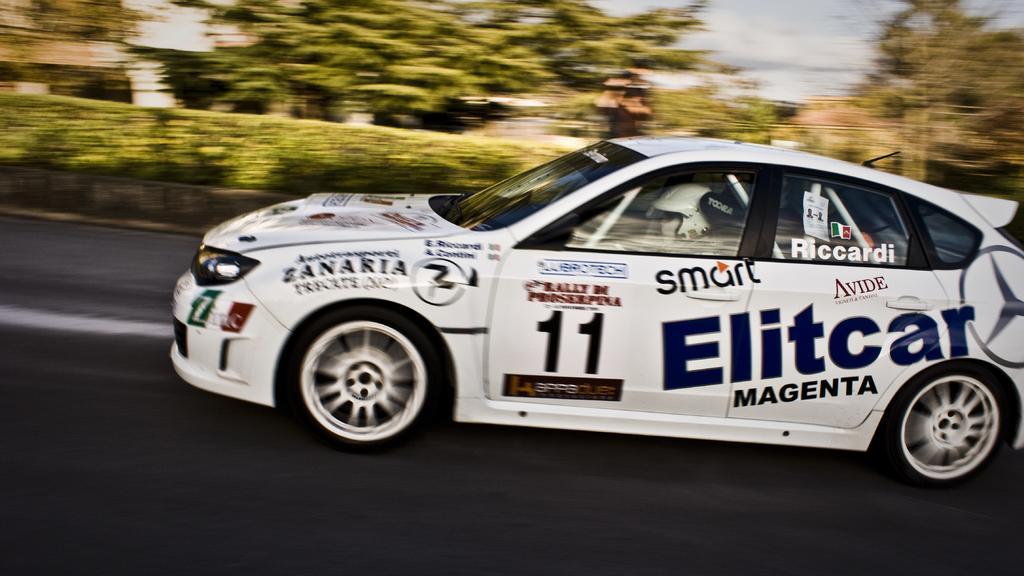Describe this image in one or two sentences. In this image, I can see a car on the road. In the background, I can see the trees and bushes. I can see a person sitting inside the car. 